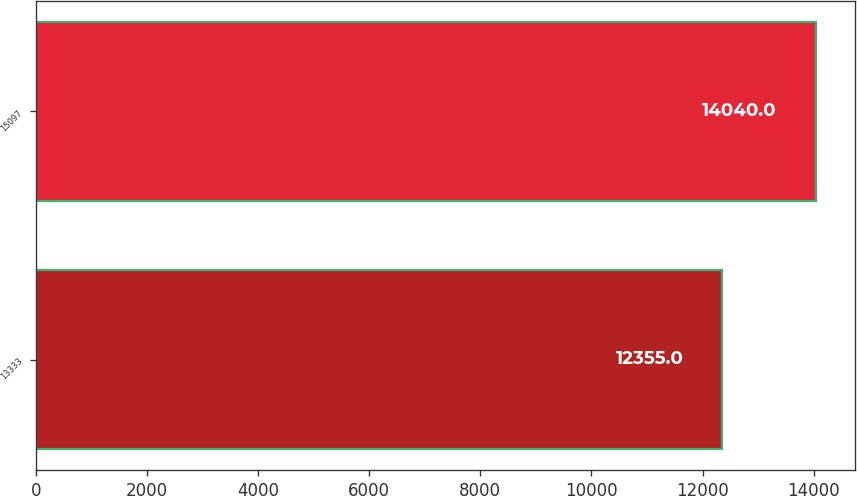<chart> <loc_0><loc_0><loc_500><loc_500><bar_chart><fcel>13333<fcel>15097<nl><fcel>12355<fcel>14040<nl></chart> 